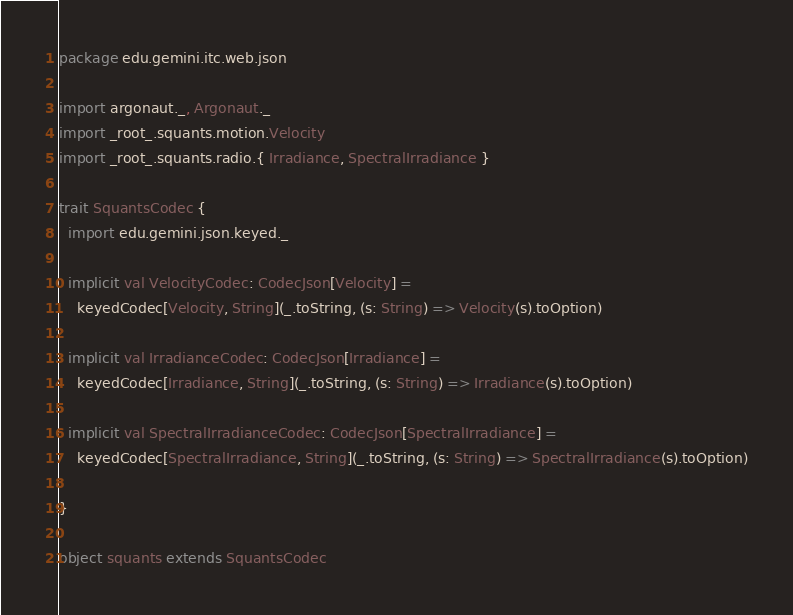<code> <loc_0><loc_0><loc_500><loc_500><_Scala_>package edu.gemini.itc.web.json

import argonaut._, Argonaut._
import _root_.squants.motion.Velocity
import _root_.squants.radio.{ Irradiance, SpectralIrradiance }

trait SquantsCodec {
  import edu.gemini.json.keyed._

  implicit val VelocityCodec: CodecJson[Velocity] =
    keyedCodec[Velocity, String](_.toString, (s: String) => Velocity(s).toOption)

  implicit val IrradianceCodec: CodecJson[Irradiance] =
    keyedCodec[Irradiance, String](_.toString, (s: String) => Irradiance(s).toOption)

  implicit val SpectralIrradianceCodec: CodecJson[SpectralIrradiance] =
    keyedCodec[SpectralIrradiance, String](_.toString, (s: String) => SpectralIrradiance(s).toOption)

}

object squants extends SquantsCodec</code> 